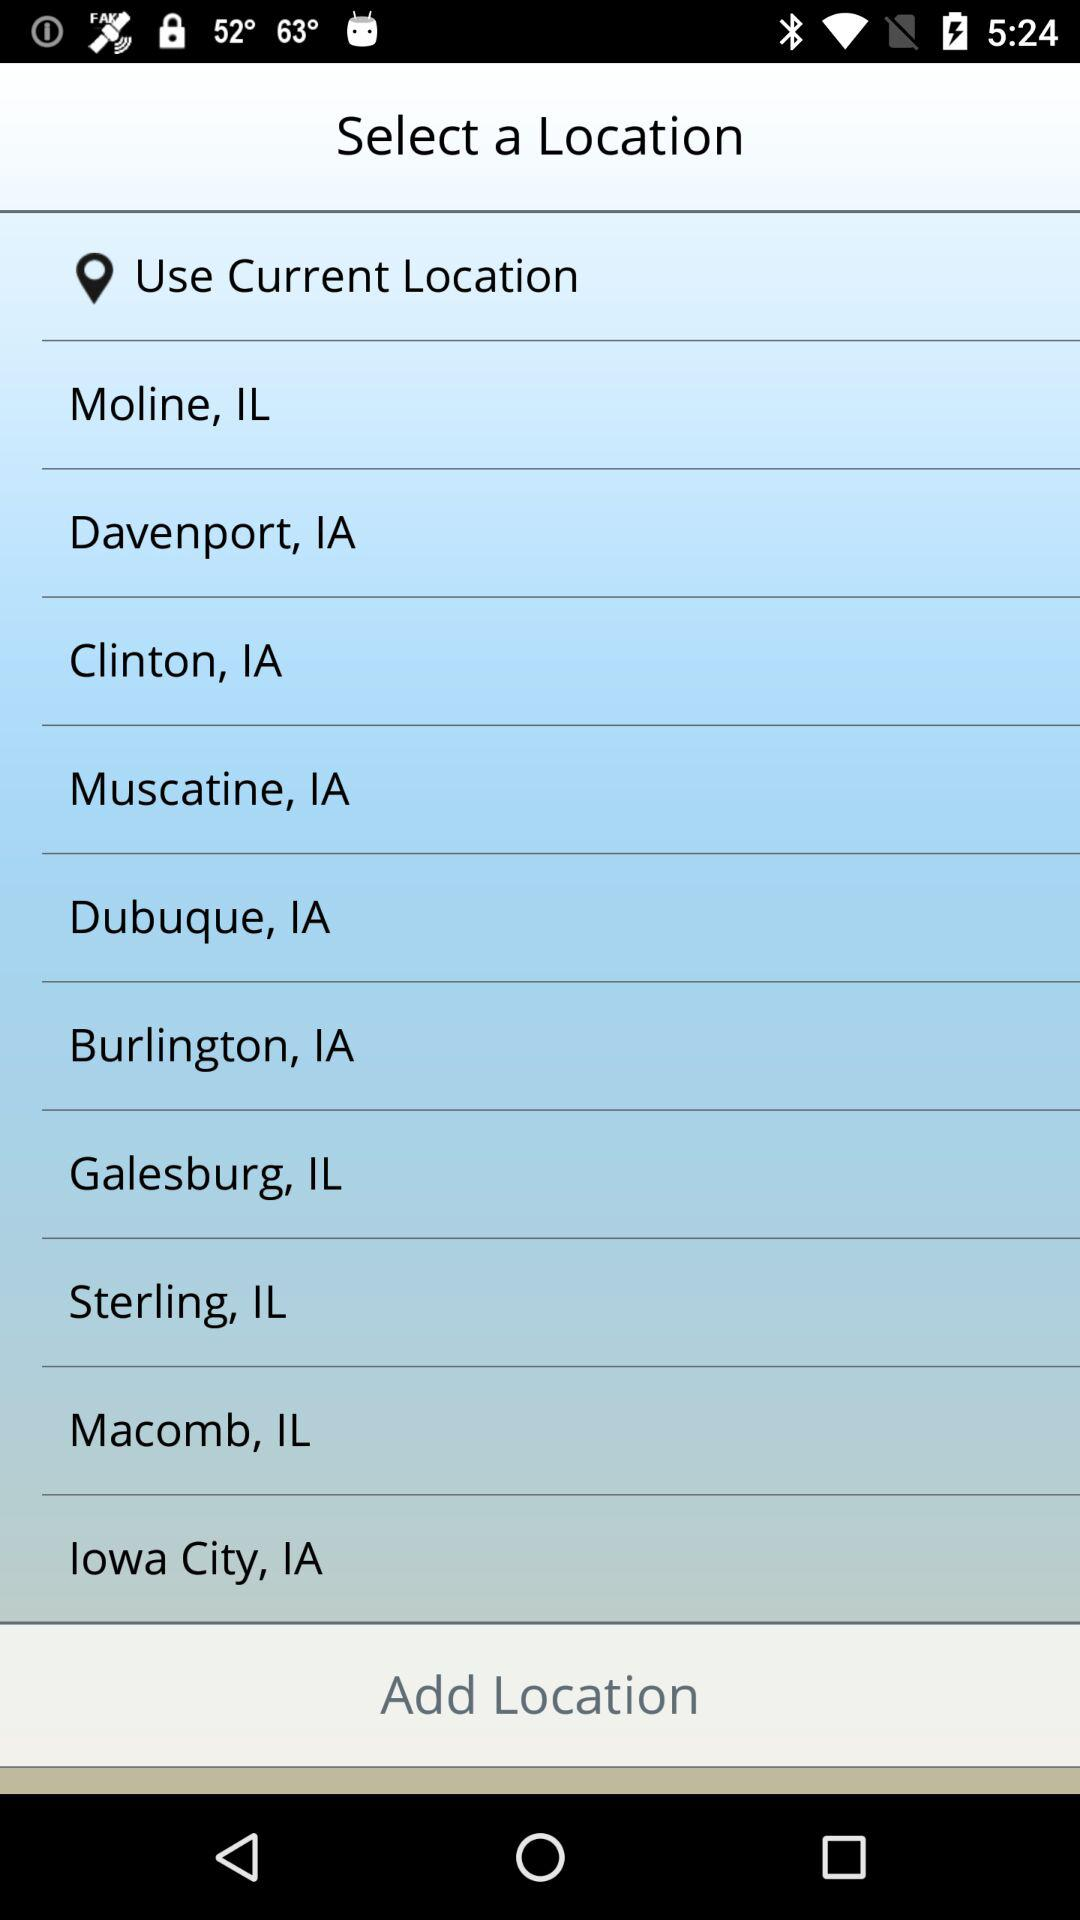Who is selecting a location?
When the provided information is insufficient, respond with <no answer>. <no answer> 